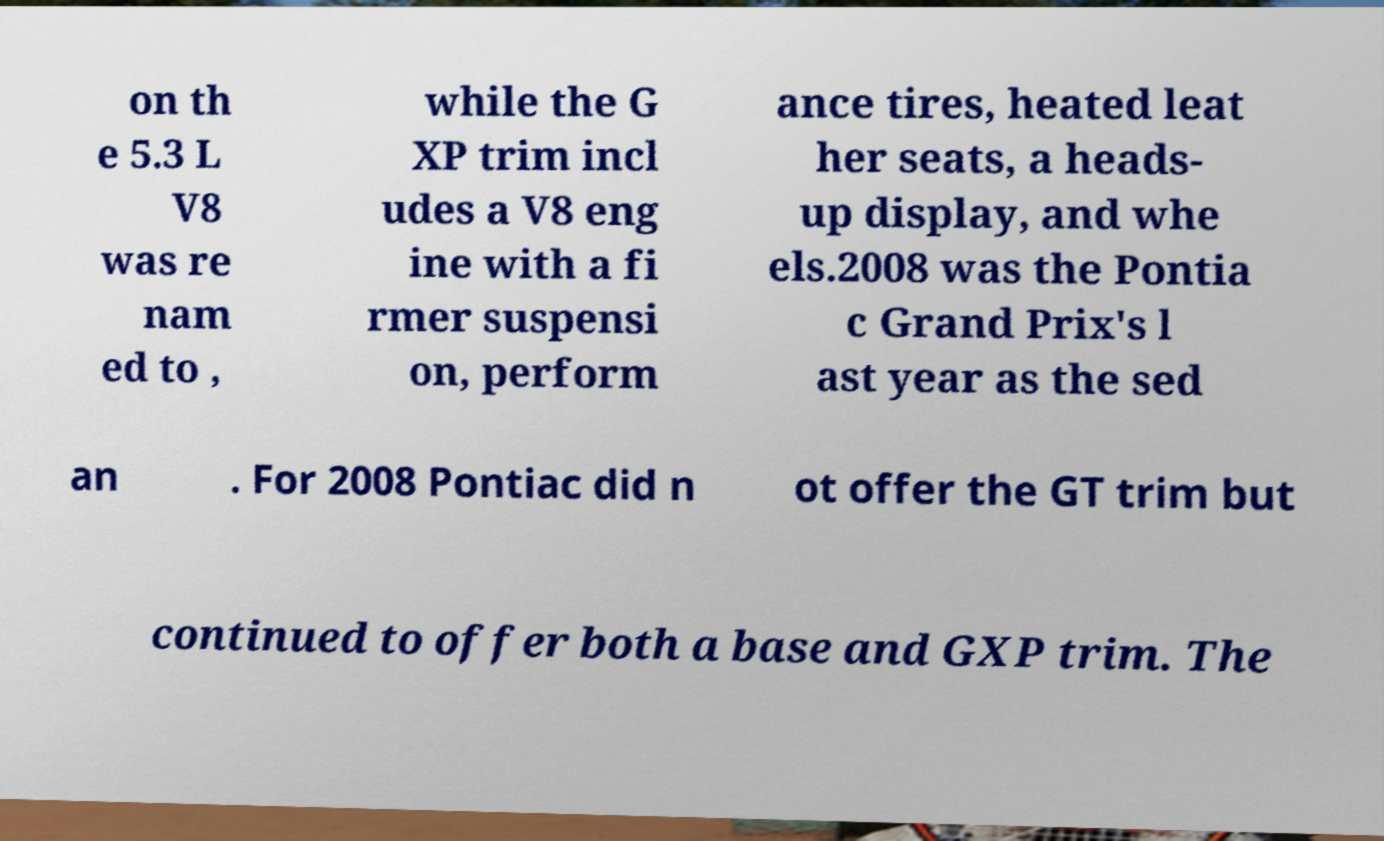There's text embedded in this image that I need extracted. Can you transcribe it verbatim? on th e 5.3 L V8 was re nam ed to , while the G XP trim incl udes a V8 eng ine with a fi rmer suspensi on, perform ance tires, heated leat her seats, a heads- up display, and whe els.2008 was the Pontia c Grand Prix's l ast year as the sed an . For 2008 Pontiac did n ot offer the GT trim but continued to offer both a base and GXP trim. The 